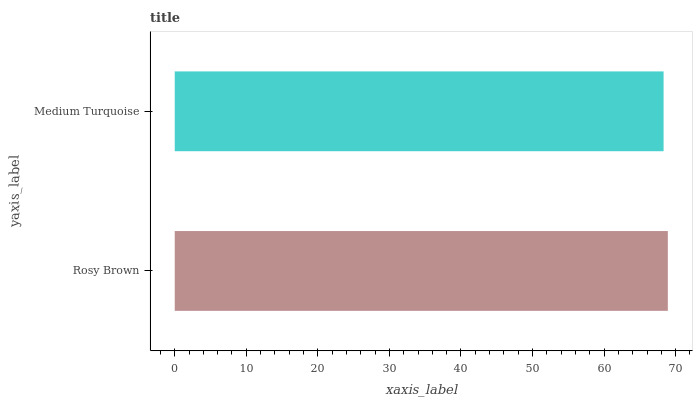Is Medium Turquoise the minimum?
Answer yes or no. Yes. Is Rosy Brown the maximum?
Answer yes or no. Yes. Is Medium Turquoise the maximum?
Answer yes or no. No. Is Rosy Brown greater than Medium Turquoise?
Answer yes or no. Yes. Is Medium Turquoise less than Rosy Brown?
Answer yes or no. Yes. Is Medium Turquoise greater than Rosy Brown?
Answer yes or no. No. Is Rosy Brown less than Medium Turquoise?
Answer yes or no. No. Is Rosy Brown the high median?
Answer yes or no. Yes. Is Medium Turquoise the low median?
Answer yes or no. Yes. Is Medium Turquoise the high median?
Answer yes or no. No. Is Rosy Brown the low median?
Answer yes or no. No. 